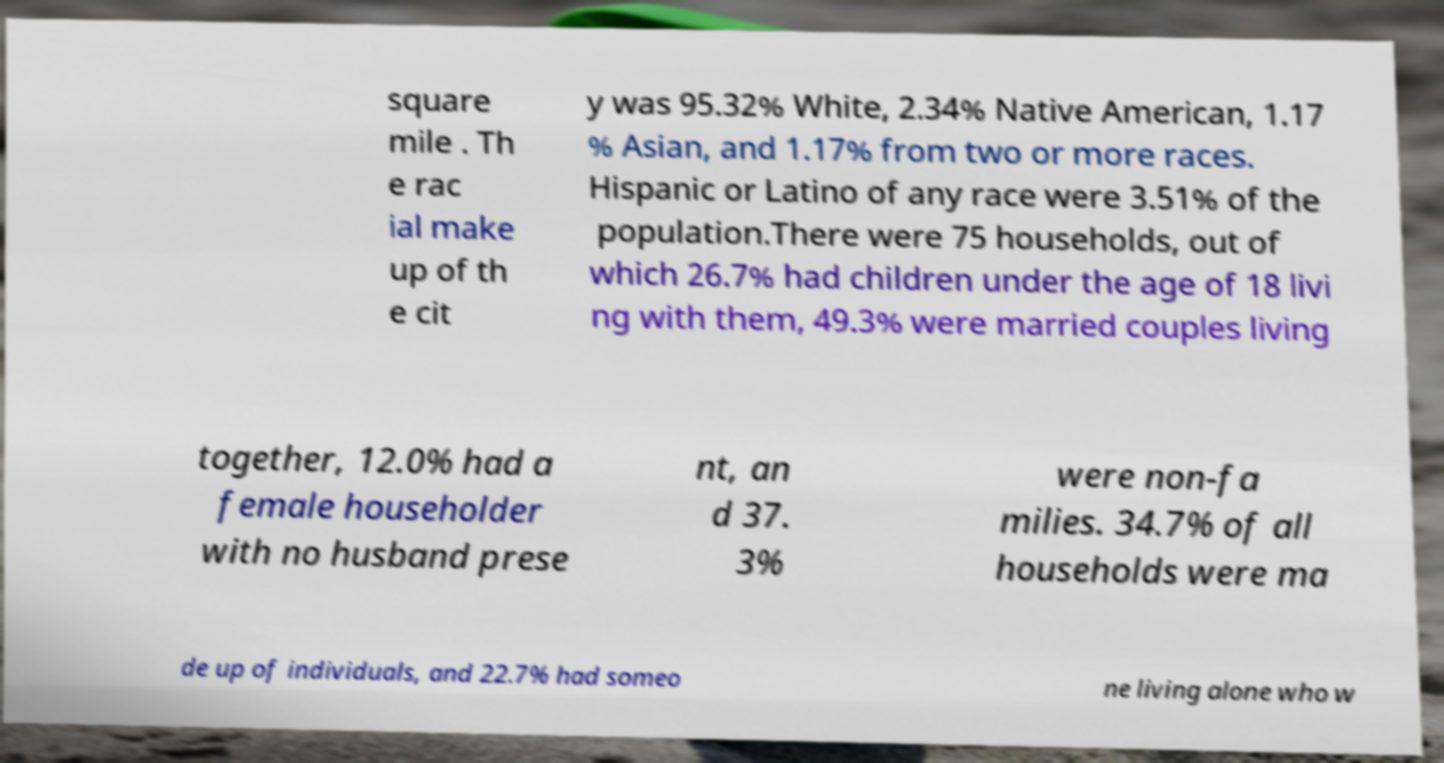For documentation purposes, I need the text within this image transcribed. Could you provide that? square mile . Th e rac ial make up of th e cit y was 95.32% White, 2.34% Native American, 1.17 % Asian, and 1.17% from two or more races. Hispanic or Latino of any race were 3.51% of the population.There were 75 households, out of which 26.7% had children under the age of 18 livi ng with them, 49.3% were married couples living together, 12.0% had a female householder with no husband prese nt, an d 37. 3% were non-fa milies. 34.7% of all households were ma de up of individuals, and 22.7% had someo ne living alone who w 